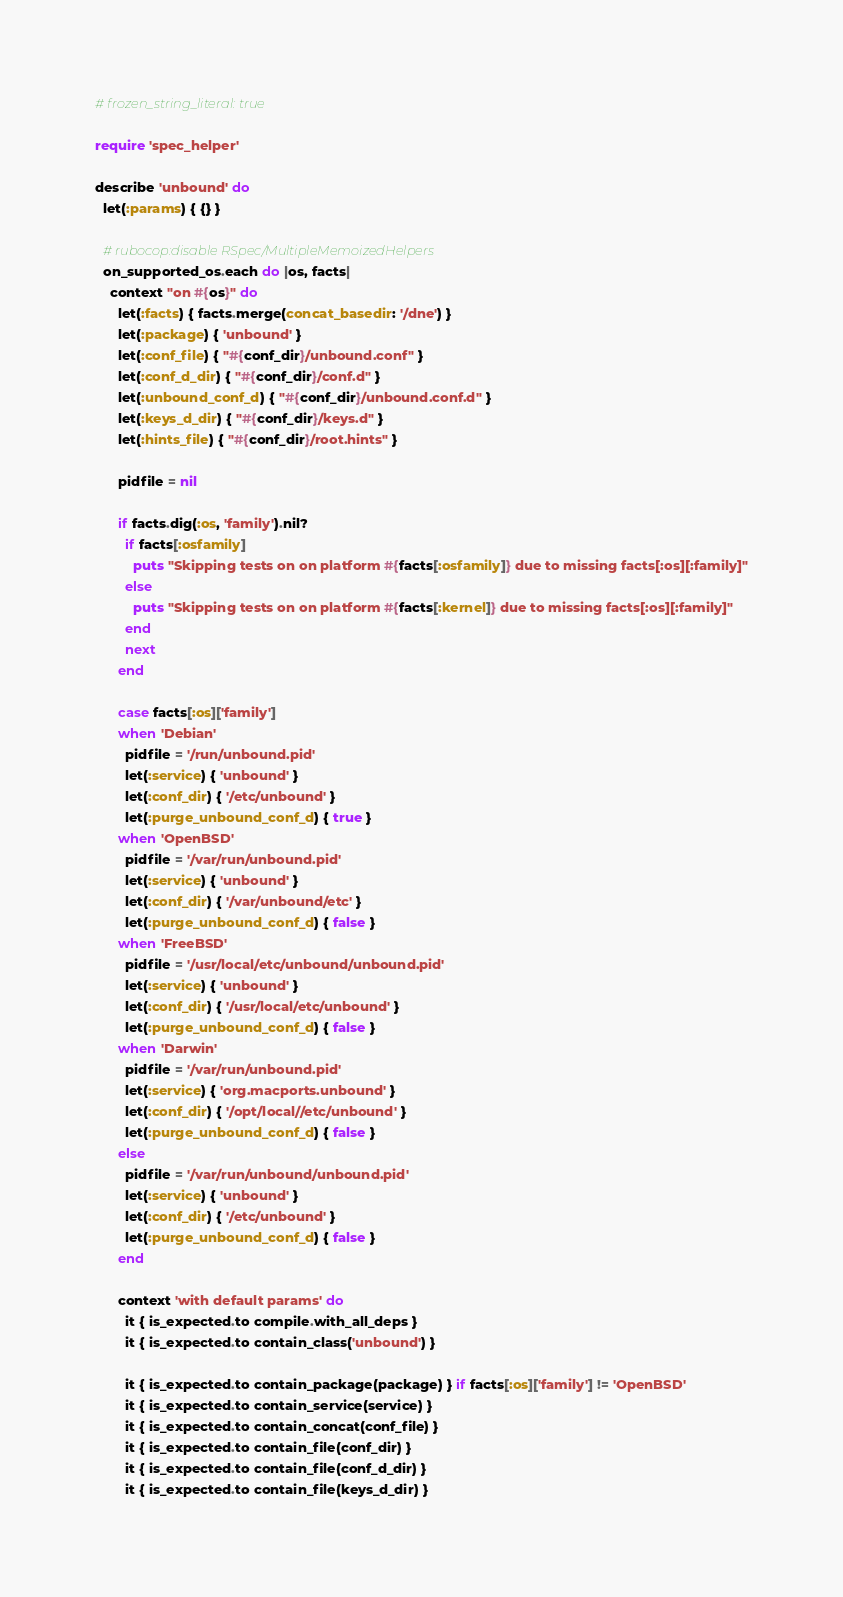<code> <loc_0><loc_0><loc_500><loc_500><_Ruby_># frozen_string_literal: true

require 'spec_helper'

describe 'unbound' do
  let(:params) { {} }

  # rubocop:disable RSpec/MultipleMemoizedHelpers
  on_supported_os.each do |os, facts|
    context "on #{os}" do
      let(:facts) { facts.merge(concat_basedir: '/dne') }
      let(:package) { 'unbound' }
      let(:conf_file) { "#{conf_dir}/unbound.conf" }
      let(:conf_d_dir) { "#{conf_dir}/conf.d" }
      let(:unbound_conf_d) { "#{conf_dir}/unbound.conf.d" }
      let(:keys_d_dir) { "#{conf_dir}/keys.d" }
      let(:hints_file) { "#{conf_dir}/root.hints" }

      pidfile = nil

      if facts.dig(:os, 'family').nil?
        if facts[:osfamily]
          puts "Skipping tests on on platform #{facts[:osfamily]} due to missing facts[:os][:family]"
        else
          puts "Skipping tests on on platform #{facts[:kernel]} due to missing facts[:os][:family]"
        end
        next
      end

      case facts[:os]['family']
      when 'Debian'
        pidfile = '/run/unbound.pid'
        let(:service) { 'unbound' }
        let(:conf_dir) { '/etc/unbound' }
        let(:purge_unbound_conf_d) { true }
      when 'OpenBSD'
        pidfile = '/var/run/unbound.pid'
        let(:service) { 'unbound' }
        let(:conf_dir) { '/var/unbound/etc' }
        let(:purge_unbound_conf_d) { false }
      when 'FreeBSD'
        pidfile = '/usr/local/etc/unbound/unbound.pid'
        let(:service) { 'unbound' }
        let(:conf_dir) { '/usr/local/etc/unbound' }
        let(:purge_unbound_conf_d) { false }
      when 'Darwin'
        pidfile = '/var/run/unbound.pid'
        let(:service) { 'org.macports.unbound' }
        let(:conf_dir) { '/opt/local//etc/unbound' }
        let(:purge_unbound_conf_d) { false }
      else
        pidfile = '/var/run/unbound/unbound.pid'
        let(:service) { 'unbound' }
        let(:conf_dir) { '/etc/unbound' }
        let(:purge_unbound_conf_d) { false }
      end

      context 'with default params' do
        it { is_expected.to compile.with_all_deps }
        it { is_expected.to contain_class('unbound') }

        it { is_expected.to contain_package(package) } if facts[:os]['family'] != 'OpenBSD'
        it { is_expected.to contain_service(service) }
        it { is_expected.to contain_concat(conf_file) }
        it { is_expected.to contain_file(conf_dir) }
        it { is_expected.to contain_file(conf_d_dir) }
        it { is_expected.to contain_file(keys_d_dir) }</code> 